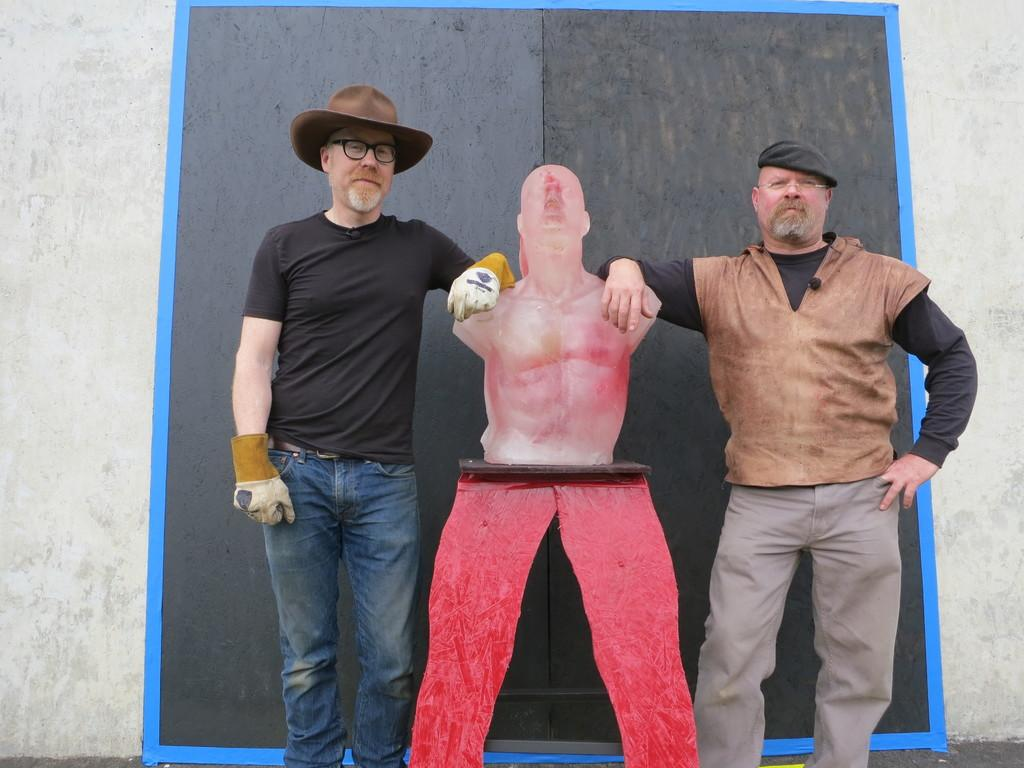Who is present in the image? There are men in the image. What are the men doing in the image? The men are standing on the floor and holding a statue. What can be seen in the background of the image? There are walls in the background of the image. What type of bottle is being used to generate ideas in the image? There is no bottle or idea generation process depicted in the image. 